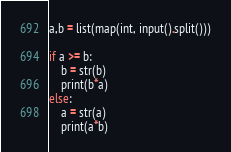Convert code to text. <code><loc_0><loc_0><loc_500><loc_500><_Python_>a,b = list(map(int, input().split()))

if a >= b:
    b = str(b)
    print(b*a)
else:
    a = str(a)
    print(a*b)</code> 